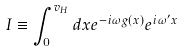<formula> <loc_0><loc_0><loc_500><loc_500>I \equiv \int _ { 0 } ^ { v _ { H } } d x e ^ { - i \omega g ( x ) } e ^ { i \omega ^ { \prime } x }</formula> 